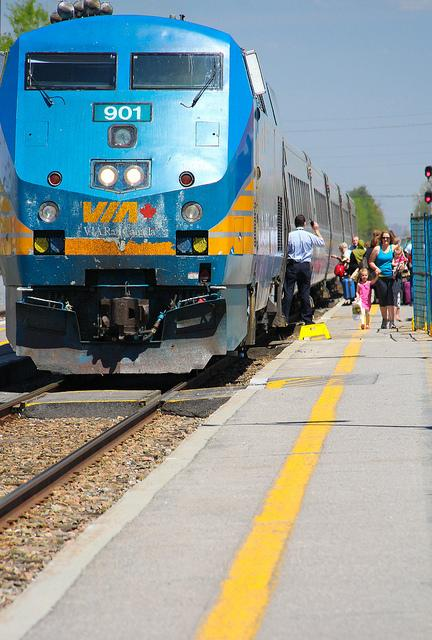What is the occupation of the man on the yellow step? conductor 